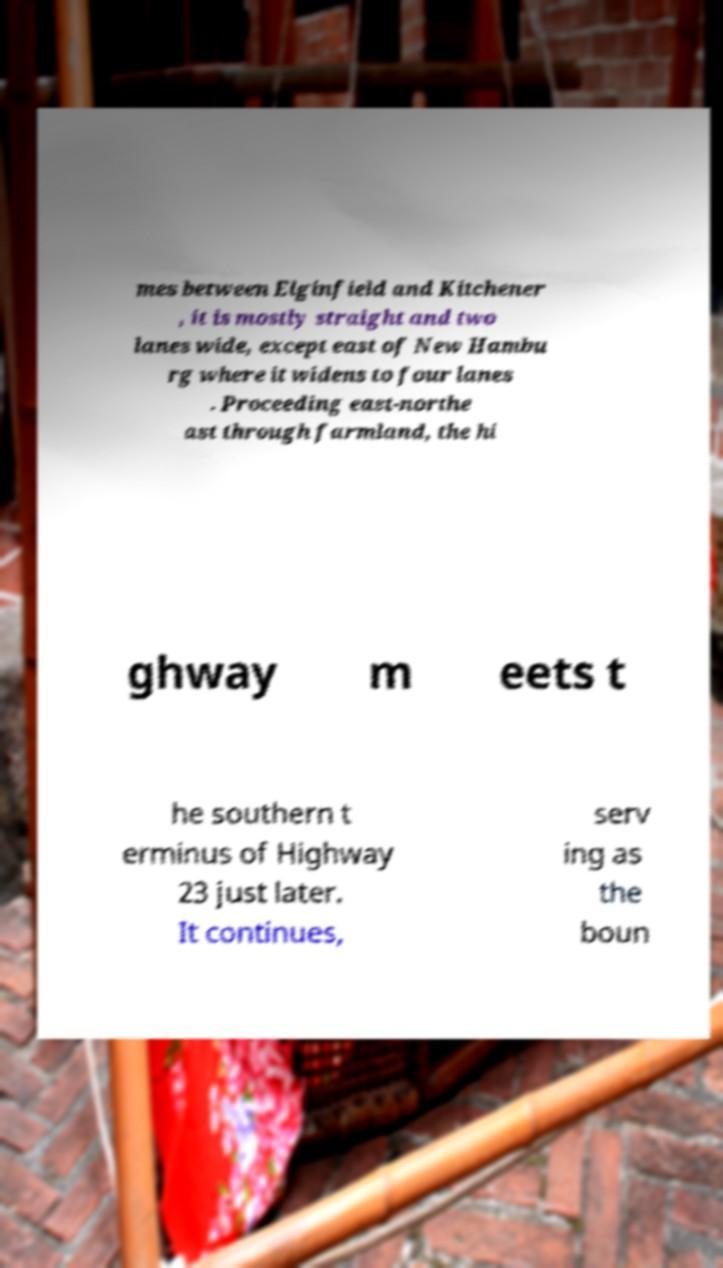There's text embedded in this image that I need extracted. Can you transcribe it verbatim? mes between Elginfield and Kitchener , it is mostly straight and two lanes wide, except east of New Hambu rg where it widens to four lanes . Proceeding east-northe ast through farmland, the hi ghway m eets t he southern t erminus of Highway 23 just later. It continues, serv ing as the boun 